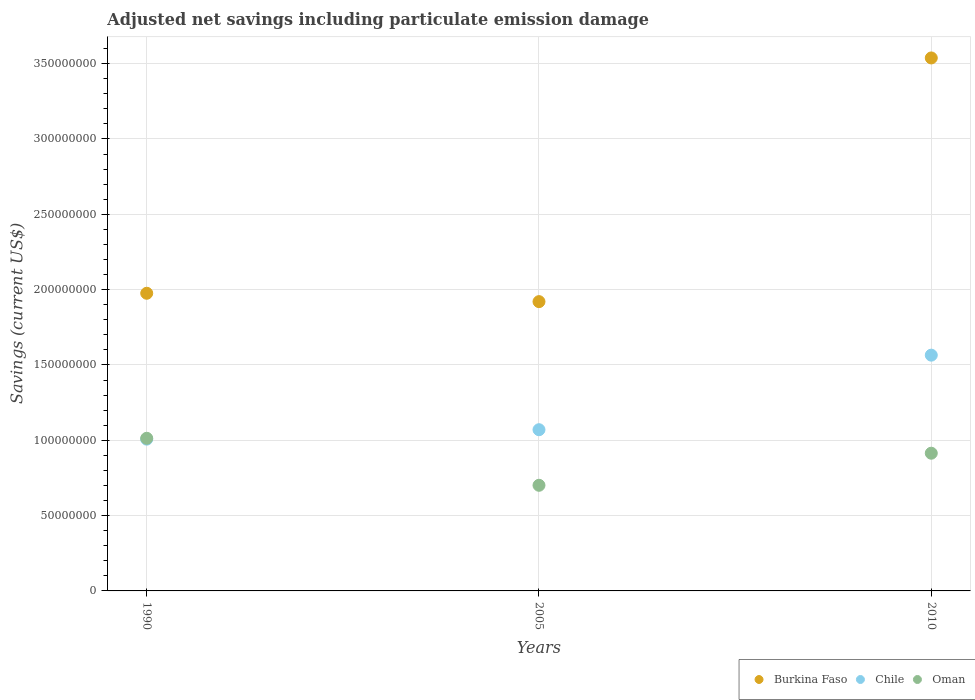Is the number of dotlines equal to the number of legend labels?
Your response must be concise. Yes. What is the net savings in Chile in 2010?
Your response must be concise. 1.56e+08. Across all years, what is the maximum net savings in Chile?
Ensure brevity in your answer.  1.56e+08. Across all years, what is the minimum net savings in Burkina Faso?
Provide a succinct answer. 1.92e+08. In which year was the net savings in Chile maximum?
Offer a very short reply. 2010. In which year was the net savings in Burkina Faso minimum?
Offer a terse response. 2005. What is the total net savings in Burkina Faso in the graph?
Ensure brevity in your answer.  7.43e+08. What is the difference between the net savings in Burkina Faso in 2005 and that in 2010?
Keep it short and to the point. -1.62e+08. What is the difference between the net savings in Chile in 1990 and the net savings in Burkina Faso in 2010?
Provide a short and direct response. -2.53e+08. What is the average net savings in Chile per year?
Keep it short and to the point. 1.21e+08. In the year 2005, what is the difference between the net savings in Oman and net savings in Burkina Faso?
Keep it short and to the point. -1.22e+08. In how many years, is the net savings in Chile greater than 300000000 US$?
Offer a terse response. 0. What is the ratio of the net savings in Burkina Faso in 1990 to that in 2005?
Offer a very short reply. 1.03. Is the net savings in Chile in 1990 less than that in 2010?
Keep it short and to the point. Yes. What is the difference between the highest and the second highest net savings in Burkina Faso?
Offer a very short reply. 1.56e+08. What is the difference between the highest and the lowest net savings in Chile?
Provide a short and direct response. 5.58e+07. Is it the case that in every year, the sum of the net savings in Oman and net savings in Chile  is greater than the net savings in Burkina Faso?
Keep it short and to the point. No. Does the net savings in Burkina Faso monotonically increase over the years?
Ensure brevity in your answer.  No. How many dotlines are there?
Provide a succinct answer. 3. How many years are there in the graph?
Ensure brevity in your answer.  3. Where does the legend appear in the graph?
Make the answer very short. Bottom right. How many legend labels are there?
Keep it short and to the point. 3. How are the legend labels stacked?
Offer a very short reply. Horizontal. What is the title of the graph?
Make the answer very short. Adjusted net savings including particulate emission damage. What is the label or title of the X-axis?
Make the answer very short. Years. What is the label or title of the Y-axis?
Provide a succinct answer. Savings (current US$). What is the Savings (current US$) of Burkina Faso in 1990?
Offer a very short reply. 1.98e+08. What is the Savings (current US$) of Chile in 1990?
Make the answer very short. 1.01e+08. What is the Savings (current US$) in Oman in 1990?
Provide a short and direct response. 1.01e+08. What is the Savings (current US$) in Burkina Faso in 2005?
Give a very brief answer. 1.92e+08. What is the Savings (current US$) in Chile in 2005?
Offer a very short reply. 1.07e+08. What is the Savings (current US$) in Oman in 2005?
Your answer should be compact. 7.01e+07. What is the Savings (current US$) in Burkina Faso in 2010?
Offer a very short reply. 3.54e+08. What is the Savings (current US$) of Chile in 2010?
Offer a terse response. 1.56e+08. What is the Savings (current US$) of Oman in 2010?
Your response must be concise. 9.14e+07. Across all years, what is the maximum Savings (current US$) of Burkina Faso?
Provide a short and direct response. 3.54e+08. Across all years, what is the maximum Savings (current US$) in Chile?
Offer a very short reply. 1.56e+08. Across all years, what is the maximum Savings (current US$) in Oman?
Make the answer very short. 1.01e+08. Across all years, what is the minimum Savings (current US$) in Burkina Faso?
Make the answer very short. 1.92e+08. Across all years, what is the minimum Savings (current US$) of Chile?
Your answer should be compact. 1.01e+08. Across all years, what is the minimum Savings (current US$) in Oman?
Make the answer very short. 7.01e+07. What is the total Savings (current US$) in Burkina Faso in the graph?
Offer a terse response. 7.43e+08. What is the total Savings (current US$) in Chile in the graph?
Your response must be concise. 3.64e+08. What is the total Savings (current US$) of Oman in the graph?
Your answer should be compact. 2.63e+08. What is the difference between the Savings (current US$) in Burkina Faso in 1990 and that in 2005?
Your response must be concise. 5.55e+06. What is the difference between the Savings (current US$) in Chile in 1990 and that in 2005?
Make the answer very short. -6.27e+06. What is the difference between the Savings (current US$) in Oman in 1990 and that in 2005?
Offer a terse response. 3.12e+07. What is the difference between the Savings (current US$) in Burkina Faso in 1990 and that in 2010?
Offer a terse response. -1.56e+08. What is the difference between the Savings (current US$) in Chile in 1990 and that in 2010?
Provide a short and direct response. -5.58e+07. What is the difference between the Savings (current US$) of Oman in 1990 and that in 2010?
Give a very brief answer. 9.91e+06. What is the difference between the Savings (current US$) of Burkina Faso in 2005 and that in 2010?
Your answer should be compact. -1.62e+08. What is the difference between the Savings (current US$) in Chile in 2005 and that in 2010?
Provide a short and direct response. -4.95e+07. What is the difference between the Savings (current US$) in Oman in 2005 and that in 2010?
Your answer should be very brief. -2.13e+07. What is the difference between the Savings (current US$) of Burkina Faso in 1990 and the Savings (current US$) of Chile in 2005?
Provide a short and direct response. 9.06e+07. What is the difference between the Savings (current US$) in Burkina Faso in 1990 and the Savings (current US$) in Oman in 2005?
Provide a succinct answer. 1.27e+08. What is the difference between the Savings (current US$) of Chile in 1990 and the Savings (current US$) of Oman in 2005?
Your answer should be very brief. 3.06e+07. What is the difference between the Savings (current US$) in Burkina Faso in 1990 and the Savings (current US$) in Chile in 2010?
Provide a succinct answer. 4.11e+07. What is the difference between the Savings (current US$) in Burkina Faso in 1990 and the Savings (current US$) in Oman in 2010?
Keep it short and to the point. 1.06e+08. What is the difference between the Savings (current US$) in Chile in 1990 and the Savings (current US$) in Oman in 2010?
Offer a terse response. 9.33e+06. What is the difference between the Savings (current US$) of Burkina Faso in 2005 and the Savings (current US$) of Chile in 2010?
Your answer should be compact. 3.55e+07. What is the difference between the Savings (current US$) of Burkina Faso in 2005 and the Savings (current US$) of Oman in 2010?
Provide a succinct answer. 1.01e+08. What is the difference between the Savings (current US$) of Chile in 2005 and the Savings (current US$) of Oman in 2010?
Keep it short and to the point. 1.56e+07. What is the average Savings (current US$) of Burkina Faso per year?
Your answer should be compact. 2.48e+08. What is the average Savings (current US$) of Chile per year?
Your answer should be compact. 1.21e+08. What is the average Savings (current US$) of Oman per year?
Offer a terse response. 8.76e+07. In the year 1990, what is the difference between the Savings (current US$) in Burkina Faso and Savings (current US$) in Chile?
Provide a succinct answer. 9.68e+07. In the year 1990, what is the difference between the Savings (current US$) of Burkina Faso and Savings (current US$) of Oman?
Offer a terse response. 9.63e+07. In the year 1990, what is the difference between the Savings (current US$) in Chile and Savings (current US$) in Oman?
Your response must be concise. -5.75e+05. In the year 2005, what is the difference between the Savings (current US$) of Burkina Faso and Savings (current US$) of Chile?
Your answer should be compact. 8.50e+07. In the year 2005, what is the difference between the Savings (current US$) in Burkina Faso and Savings (current US$) in Oman?
Your response must be concise. 1.22e+08. In the year 2005, what is the difference between the Savings (current US$) in Chile and Savings (current US$) in Oman?
Ensure brevity in your answer.  3.69e+07. In the year 2010, what is the difference between the Savings (current US$) of Burkina Faso and Savings (current US$) of Chile?
Offer a very short reply. 1.97e+08. In the year 2010, what is the difference between the Savings (current US$) in Burkina Faso and Savings (current US$) in Oman?
Your answer should be very brief. 2.62e+08. In the year 2010, what is the difference between the Savings (current US$) of Chile and Savings (current US$) of Oman?
Give a very brief answer. 6.51e+07. What is the ratio of the Savings (current US$) of Burkina Faso in 1990 to that in 2005?
Provide a succinct answer. 1.03. What is the ratio of the Savings (current US$) in Chile in 1990 to that in 2005?
Your answer should be very brief. 0.94. What is the ratio of the Savings (current US$) of Oman in 1990 to that in 2005?
Provide a short and direct response. 1.44. What is the ratio of the Savings (current US$) in Burkina Faso in 1990 to that in 2010?
Your answer should be compact. 0.56. What is the ratio of the Savings (current US$) in Chile in 1990 to that in 2010?
Provide a short and direct response. 0.64. What is the ratio of the Savings (current US$) of Oman in 1990 to that in 2010?
Make the answer very short. 1.11. What is the ratio of the Savings (current US$) of Burkina Faso in 2005 to that in 2010?
Provide a short and direct response. 0.54. What is the ratio of the Savings (current US$) in Chile in 2005 to that in 2010?
Provide a short and direct response. 0.68. What is the ratio of the Savings (current US$) in Oman in 2005 to that in 2010?
Offer a very short reply. 0.77. What is the difference between the highest and the second highest Savings (current US$) in Burkina Faso?
Keep it short and to the point. 1.56e+08. What is the difference between the highest and the second highest Savings (current US$) of Chile?
Your answer should be very brief. 4.95e+07. What is the difference between the highest and the second highest Savings (current US$) in Oman?
Keep it short and to the point. 9.91e+06. What is the difference between the highest and the lowest Savings (current US$) of Burkina Faso?
Your answer should be compact. 1.62e+08. What is the difference between the highest and the lowest Savings (current US$) in Chile?
Your response must be concise. 5.58e+07. What is the difference between the highest and the lowest Savings (current US$) in Oman?
Provide a succinct answer. 3.12e+07. 